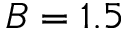<formula> <loc_0><loc_0><loc_500><loc_500>B = 1 . 5</formula> 